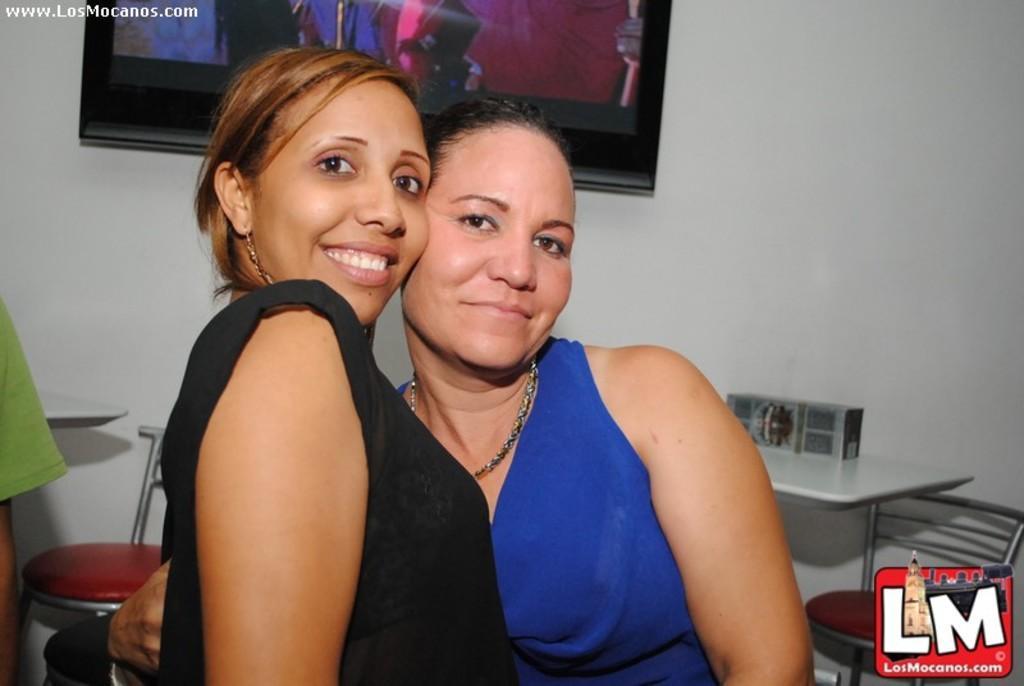Describe this image in one or two sentences. In the image we can see two persons they were smiling. In the background there is a wall,photo frame,table,chairs and two persons. 